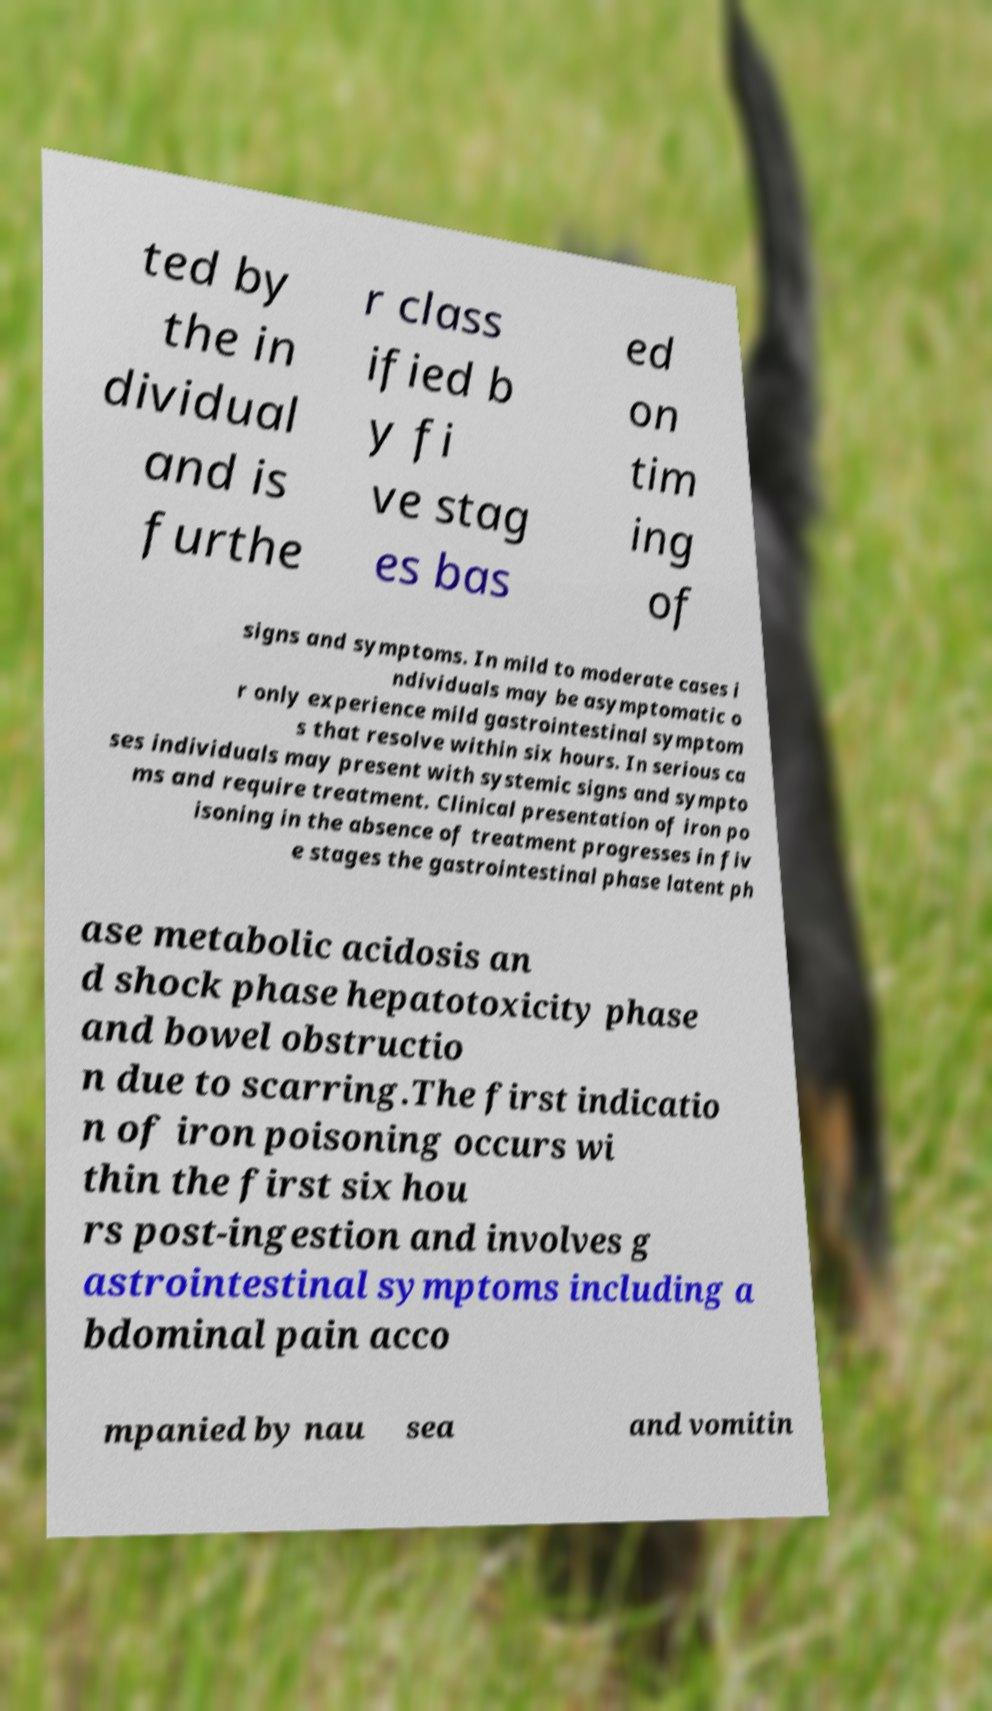There's text embedded in this image that I need extracted. Can you transcribe it verbatim? ted by the in dividual and is furthe r class ified b y fi ve stag es bas ed on tim ing of signs and symptoms. In mild to moderate cases i ndividuals may be asymptomatic o r only experience mild gastrointestinal symptom s that resolve within six hours. In serious ca ses individuals may present with systemic signs and sympto ms and require treatment. Clinical presentation of iron po isoning in the absence of treatment progresses in fiv e stages the gastrointestinal phase latent ph ase metabolic acidosis an d shock phase hepatotoxicity phase and bowel obstructio n due to scarring.The first indicatio n of iron poisoning occurs wi thin the first six hou rs post-ingestion and involves g astrointestinal symptoms including a bdominal pain acco mpanied by nau sea and vomitin 